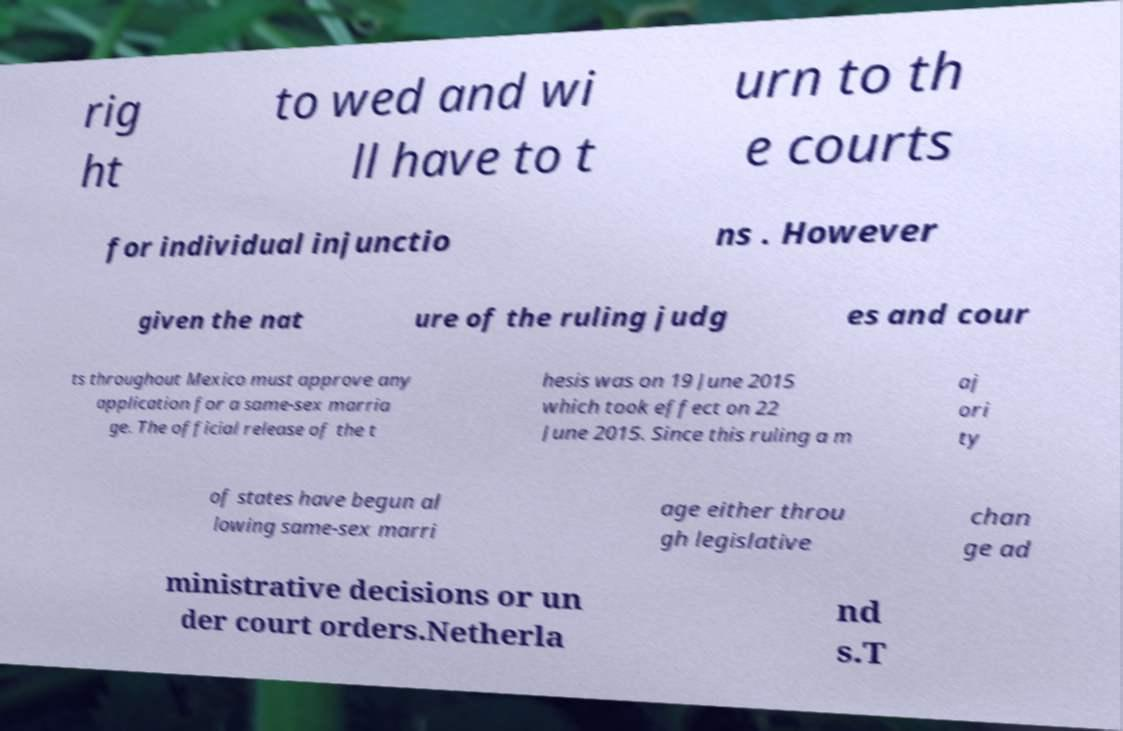For documentation purposes, I need the text within this image transcribed. Could you provide that? rig ht to wed and wi ll have to t urn to th e courts for individual injunctio ns . However given the nat ure of the ruling judg es and cour ts throughout Mexico must approve any application for a same-sex marria ge. The official release of the t hesis was on 19 June 2015 which took effect on 22 June 2015. Since this ruling a m aj ori ty of states have begun al lowing same-sex marri age either throu gh legislative chan ge ad ministrative decisions or un der court orders.Netherla nd s.T 